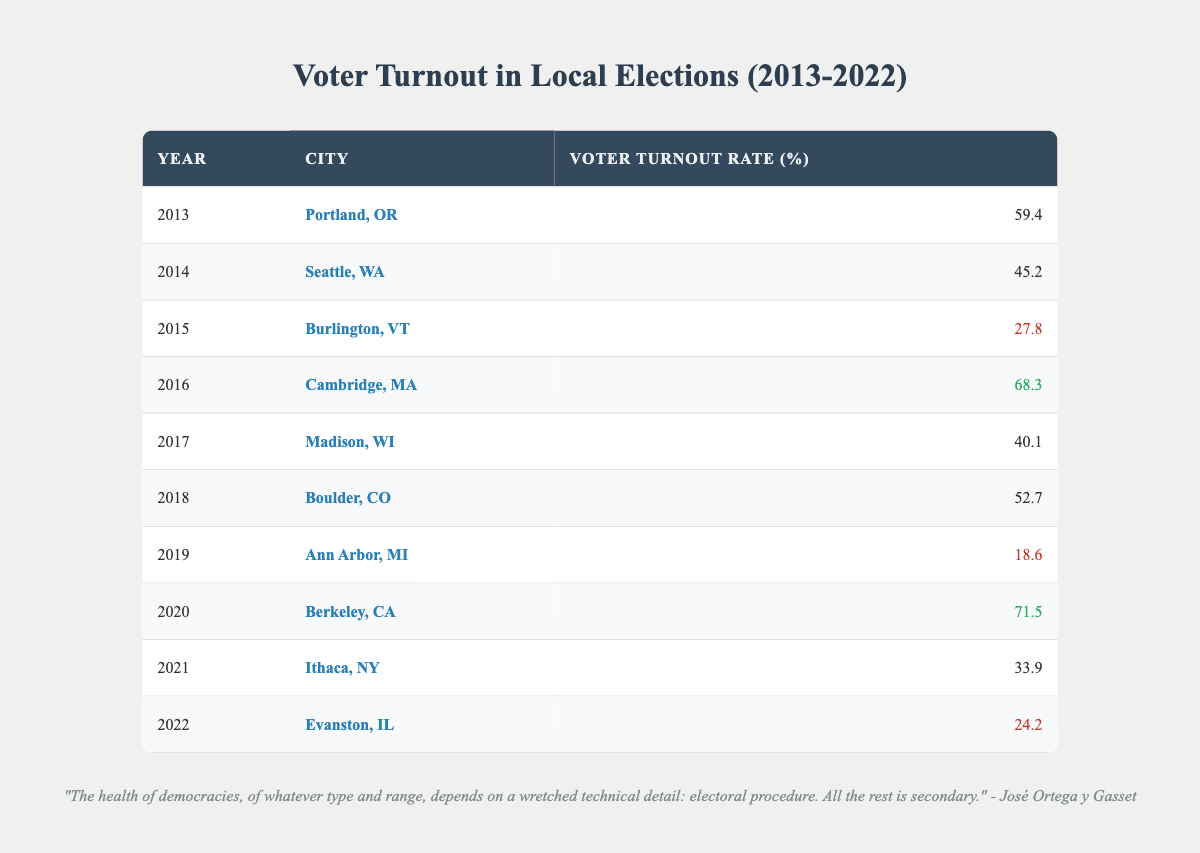What was the voter turnout rate in Berkeley, CA in 2020? The table shows the row for 2020 and indicates that the voter turnout rate for Berkeley, CA is 71.5%.
Answer: 71.5% Which city had the lowest voter turnout rate in the data? By examining the voter turnout rates listed for each city, Ann Arbor, MI in 2019 has the lowest rate of 18.6%.
Answer: Ann Arbor, MI What is the average voter turnout rate for the years 2013 to 2018? First, sum the voter turnout rates for the years 2013 to 2018: 59.4 + 45.2 + 27.8 + 68.3 + 40.1 + 52.7 = 293.5. Then, divide this sum by the number of years (6), which equals 293.5 / 6 = 48.92.
Answer: 48.92 Was the voter turnout rate in Cambridge, MA higher than that in Portland, OR? Looking at the voter turnout rates, Cambridge, MA had a rate of 68.3% while Portland, OR had a rate of 59.4%. Since 68.3% is greater than 59.4%, the answer is yes.
Answer: Yes What was the total voter turnout rate for the year 2021? In 2021, the data indicates that the voter turnout rate in Ithaca, NY was 33.9%. Since there are no other values for that year, the total for 2021 is simply this rate.
Answer: 33.9 Which years had a voter turnout rate above 60%? By reviewing the table, the years with a turnout rate above 60% are 2016 (68.3%), and 2020 (71.5%). Both rates exceed 60%.
Answer: 2016, 2020 What is the difference in voter turnout rates between 2016 and 2022? The voter turnout rate for 2016 is 68.3% and for 2022 is 24.2%. Calculate the difference: 68.3 - 24.2 = 44.1.
Answer: 44.1 How many cities had a voter turnout rate below 30%? Reviewing the table, Burlington, VT (2015) at 27.8%, Ann Arbor, MI (2019) at 18.6%, and Evanston, IL (2022) at 24.2% all had rates below 30%. This gives a total of 3 cities.
Answer: 3 What was the voter turnout in Portland, OR, and how does it compare to that in Seattle, WA? The voter turnout for Portland, OR in 2013 was 59.4%, while for Seattle, WA in 2014 it was 45.2%. Comparing these, Portland, OR had a higher turnout rate than Seattle, WA.
Answer: Higher 